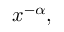Convert formula to latex. <formula><loc_0><loc_0><loc_500><loc_500>x ^ { - \alpha } ,</formula> 